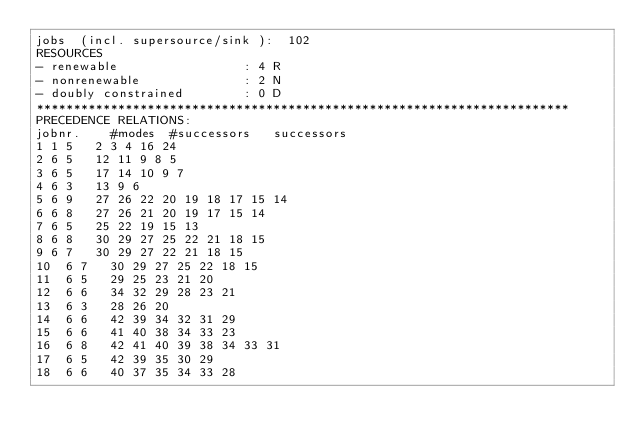<code> <loc_0><loc_0><loc_500><loc_500><_ObjectiveC_>jobs  (incl. supersource/sink ):	102
RESOURCES
- renewable                 : 4 R
- nonrenewable              : 2 N
- doubly constrained        : 0 D
************************************************************************
PRECEDENCE RELATIONS:
jobnr.    #modes  #successors   successors
1	1	5		2 3 4 16 24 
2	6	5		12 11 9 8 5 
3	6	5		17 14 10 9 7 
4	6	3		13 9 6 
5	6	9		27 26 22 20 19 18 17 15 14 
6	6	8		27 26 21 20 19 17 15 14 
7	6	5		25 22 19 15 13 
8	6	8		30 29 27 25 22 21 18 15 
9	6	7		30 29 27 22 21 18 15 
10	6	7		30 29 27 25 22 18 15 
11	6	5		29 25 23 21 20 
12	6	6		34 32 29 28 23 21 
13	6	3		28 26 20 
14	6	6		42 39 34 32 31 29 
15	6	6		41 40 38 34 33 23 
16	6	8		42 41 40 39 38 34 33 31 
17	6	5		42 39 35 30 29 
18	6	6		40 37 35 34 33 28 </code> 